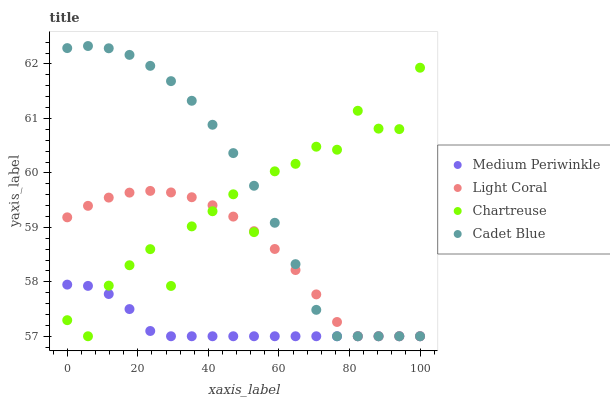Does Medium Periwinkle have the minimum area under the curve?
Answer yes or no. Yes. Does Cadet Blue have the maximum area under the curve?
Answer yes or no. Yes. Does Chartreuse have the minimum area under the curve?
Answer yes or no. No. Does Chartreuse have the maximum area under the curve?
Answer yes or no. No. Is Medium Periwinkle the smoothest?
Answer yes or no. Yes. Is Chartreuse the roughest?
Answer yes or no. Yes. Is Cadet Blue the smoothest?
Answer yes or no. No. Is Cadet Blue the roughest?
Answer yes or no. No. Does Light Coral have the lowest value?
Answer yes or no. Yes. Does Cadet Blue have the highest value?
Answer yes or no. Yes. Does Chartreuse have the highest value?
Answer yes or no. No. Does Medium Periwinkle intersect Cadet Blue?
Answer yes or no. Yes. Is Medium Periwinkle less than Cadet Blue?
Answer yes or no. No. Is Medium Periwinkle greater than Cadet Blue?
Answer yes or no. No. 